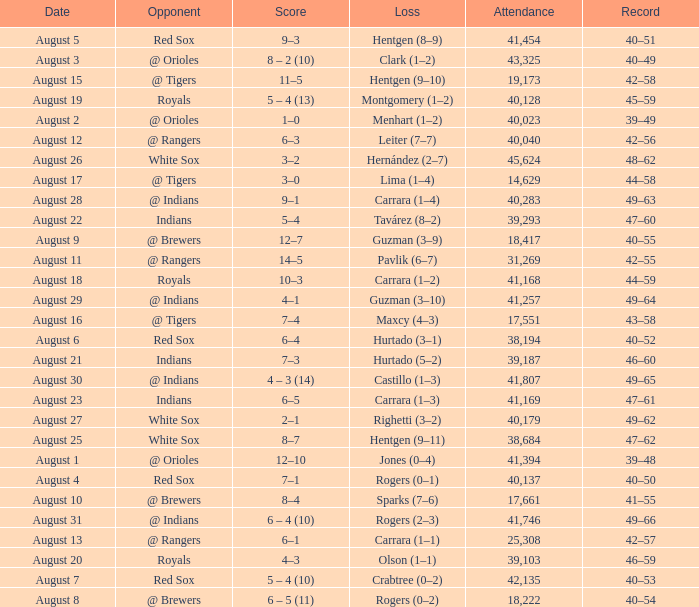Who did they play on August 12? @ Rangers. 